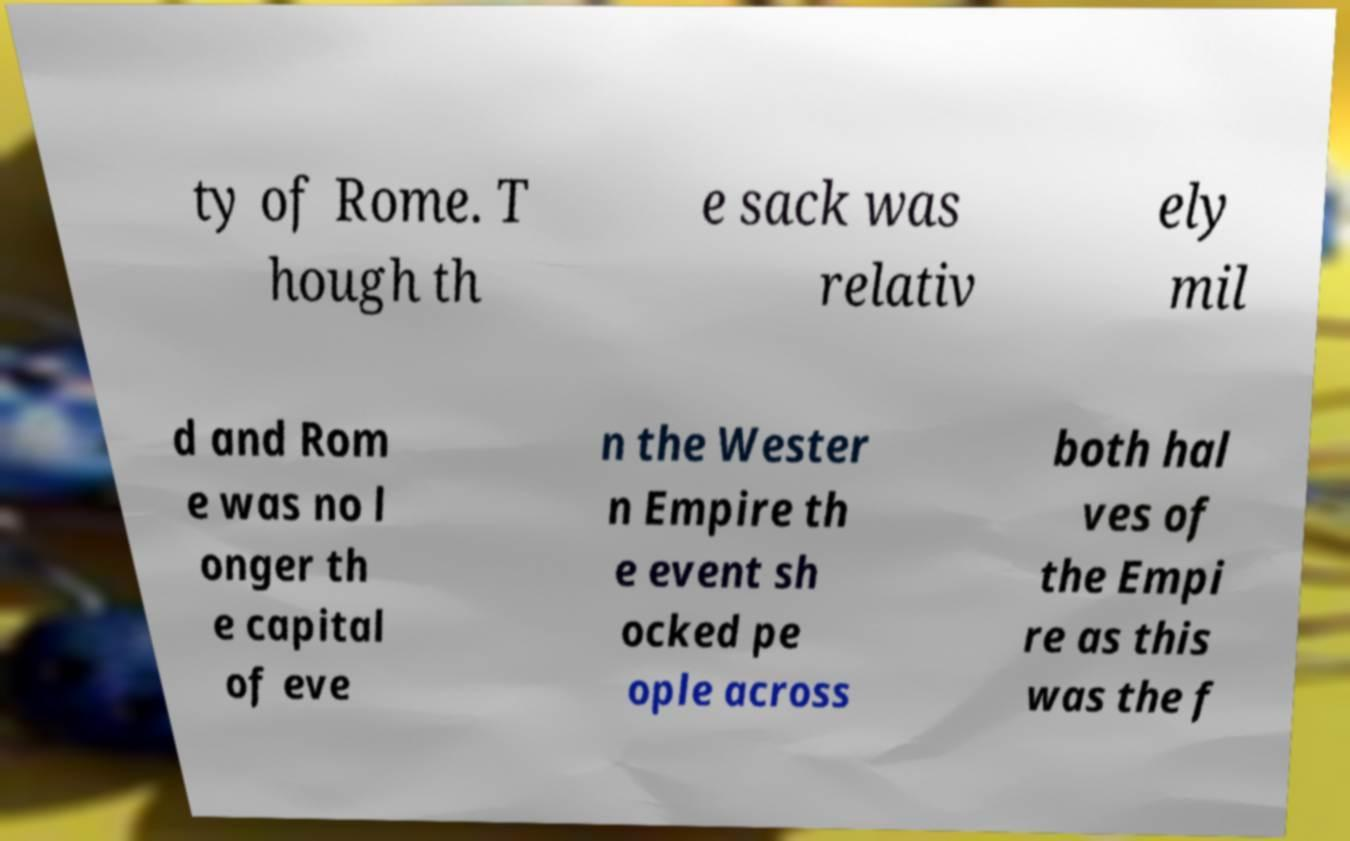Could you assist in decoding the text presented in this image and type it out clearly? ty of Rome. T hough th e sack was relativ ely mil d and Rom e was no l onger th e capital of eve n the Wester n Empire th e event sh ocked pe ople across both hal ves of the Empi re as this was the f 